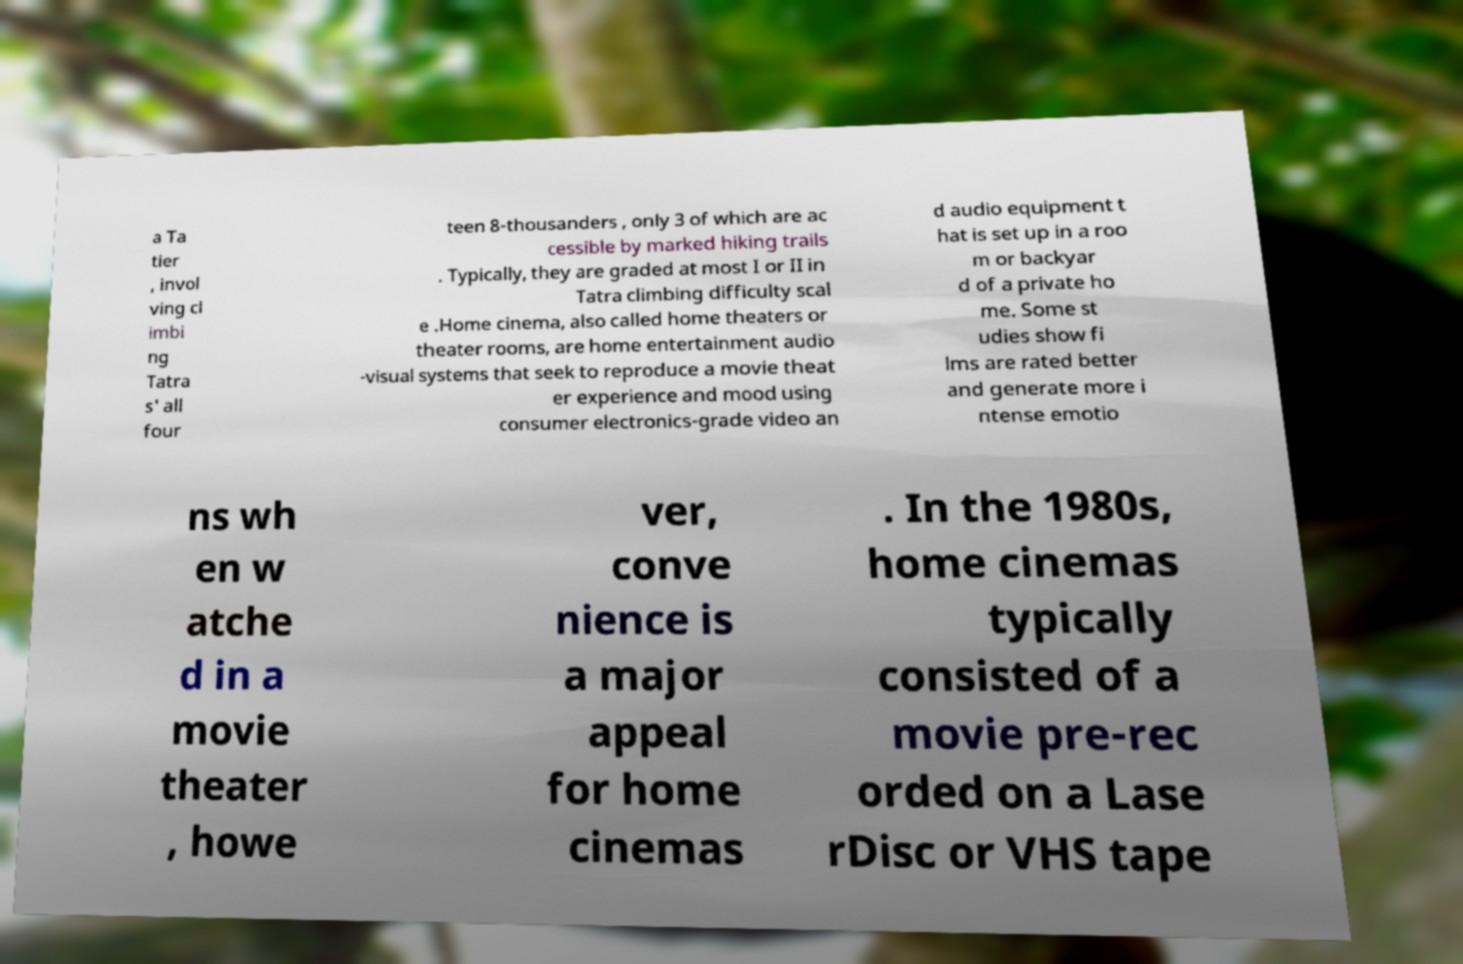Please read and relay the text visible in this image. What does it say? a Ta tier , invol ving cl imbi ng Tatra s' all four teen 8-thousanders , only 3 of which are ac cessible by marked hiking trails . Typically, they are graded at most I or II in Tatra climbing difficulty scal e .Home cinema, also called home theaters or theater rooms, are home entertainment audio -visual systems that seek to reproduce a movie theat er experience and mood using consumer electronics-grade video an d audio equipment t hat is set up in a roo m or backyar d of a private ho me. Some st udies show fi lms are rated better and generate more i ntense emotio ns wh en w atche d in a movie theater , howe ver, conve nience is a major appeal for home cinemas . In the 1980s, home cinemas typically consisted of a movie pre-rec orded on a Lase rDisc or VHS tape 